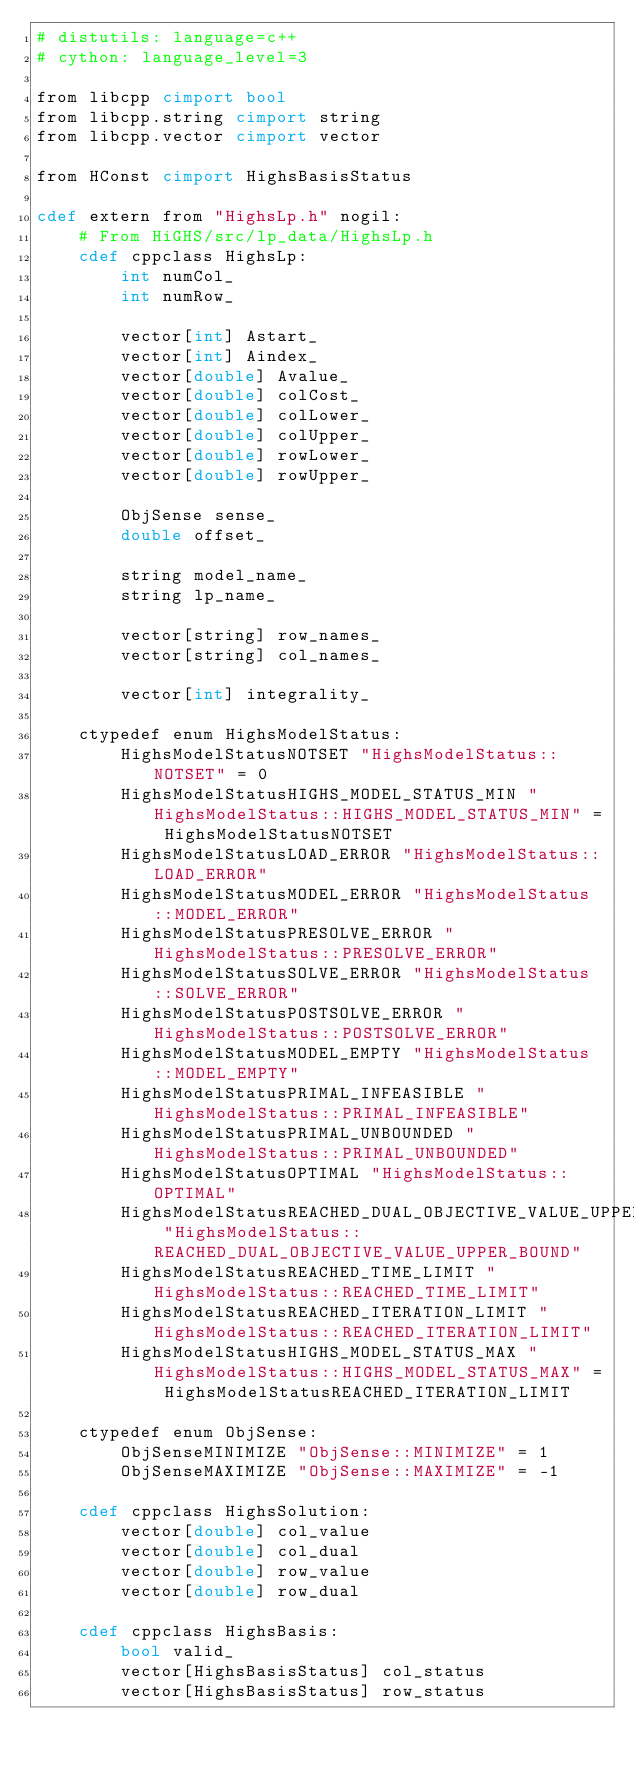<code> <loc_0><loc_0><loc_500><loc_500><_Cython_># distutils: language=c++
# cython: language_level=3

from libcpp cimport bool
from libcpp.string cimport string
from libcpp.vector cimport vector

from HConst cimport HighsBasisStatus

cdef extern from "HighsLp.h" nogil:
    # From HiGHS/src/lp_data/HighsLp.h
    cdef cppclass HighsLp:
        int numCol_
        int numRow_

        vector[int] Astart_
        vector[int] Aindex_
        vector[double] Avalue_
        vector[double] colCost_
        vector[double] colLower_
        vector[double] colUpper_
        vector[double] rowLower_
        vector[double] rowUpper_

        ObjSense sense_
        double offset_

        string model_name_
        string lp_name_

        vector[string] row_names_
        vector[string] col_names_

        vector[int] integrality_

    ctypedef enum HighsModelStatus:
        HighsModelStatusNOTSET "HighsModelStatus::NOTSET" = 0
        HighsModelStatusHIGHS_MODEL_STATUS_MIN "HighsModelStatus::HIGHS_MODEL_STATUS_MIN" = HighsModelStatusNOTSET
        HighsModelStatusLOAD_ERROR "HighsModelStatus::LOAD_ERROR"
        HighsModelStatusMODEL_ERROR "HighsModelStatus::MODEL_ERROR"
        HighsModelStatusPRESOLVE_ERROR "HighsModelStatus::PRESOLVE_ERROR"
        HighsModelStatusSOLVE_ERROR "HighsModelStatus::SOLVE_ERROR"
        HighsModelStatusPOSTSOLVE_ERROR "HighsModelStatus::POSTSOLVE_ERROR"
        HighsModelStatusMODEL_EMPTY "HighsModelStatus::MODEL_EMPTY"
        HighsModelStatusPRIMAL_INFEASIBLE "HighsModelStatus::PRIMAL_INFEASIBLE"
        HighsModelStatusPRIMAL_UNBOUNDED "HighsModelStatus::PRIMAL_UNBOUNDED"
        HighsModelStatusOPTIMAL "HighsModelStatus::OPTIMAL"
        HighsModelStatusREACHED_DUAL_OBJECTIVE_VALUE_UPPER_BOUND "HighsModelStatus::REACHED_DUAL_OBJECTIVE_VALUE_UPPER_BOUND"
        HighsModelStatusREACHED_TIME_LIMIT "HighsModelStatus::REACHED_TIME_LIMIT"
        HighsModelStatusREACHED_ITERATION_LIMIT "HighsModelStatus::REACHED_ITERATION_LIMIT"
        HighsModelStatusHIGHS_MODEL_STATUS_MAX "HighsModelStatus::HIGHS_MODEL_STATUS_MAX" = HighsModelStatusREACHED_ITERATION_LIMIT

    ctypedef enum ObjSense:
        ObjSenseMINIMIZE "ObjSense::MINIMIZE" = 1
        ObjSenseMAXIMIZE "ObjSense::MAXIMIZE" = -1

    cdef cppclass HighsSolution:
        vector[double] col_value
        vector[double] col_dual
        vector[double] row_value
        vector[double] row_dual

    cdef cppclass HighsBasis:
        bool valid_
        vector[HighsBasisStatus] col_status
        vector[HighsBasisStatus] row_status
</code> 